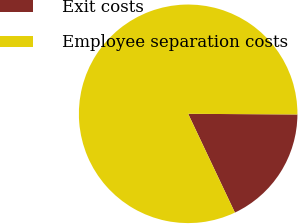Convert chart. <chart><loc_0><loc_0><loc_500><loc_500><pie_chart><fcel>Exit costs<fcel>Employee separation costs<nl><fcel>17.87%<fcel>82.13%<nl></chart> 